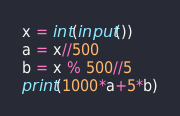Convert code to text. <code><loc_0><loc_0><loc_500><loc_500><_Python_>x = int(input())
a = x//500
b = x % 500//5
print(1000*a+5*b)
</code> 